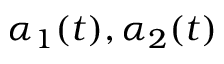<formula> <loc_0><loc_0><loc_500><loc_500>\alpha _ { 1 } ( t ) , \alpha _ { 2 } ( t )</formula> 